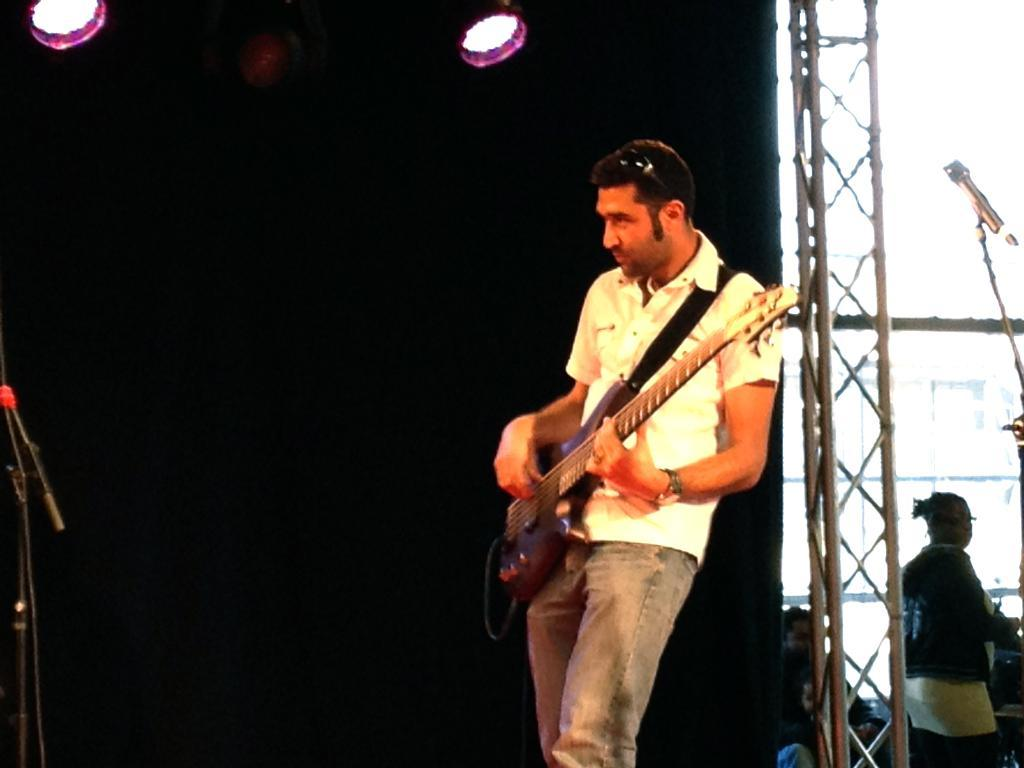What is the man in the image doing? The man is playing a guitar in the image. What can be seen in the background of the image? There are lights visible in the image. What object is present for amplifying sound? There is a microphone (mike) in the image. How many people are in the image? There is one person in the image, which is the man playing the guitar. What type of nerve is visible in the image? There is no nerve visible in the image; it features a man playing a guitar, lights, and a microphone. Is there a prison in the image? No, there is no prison present in the image. 